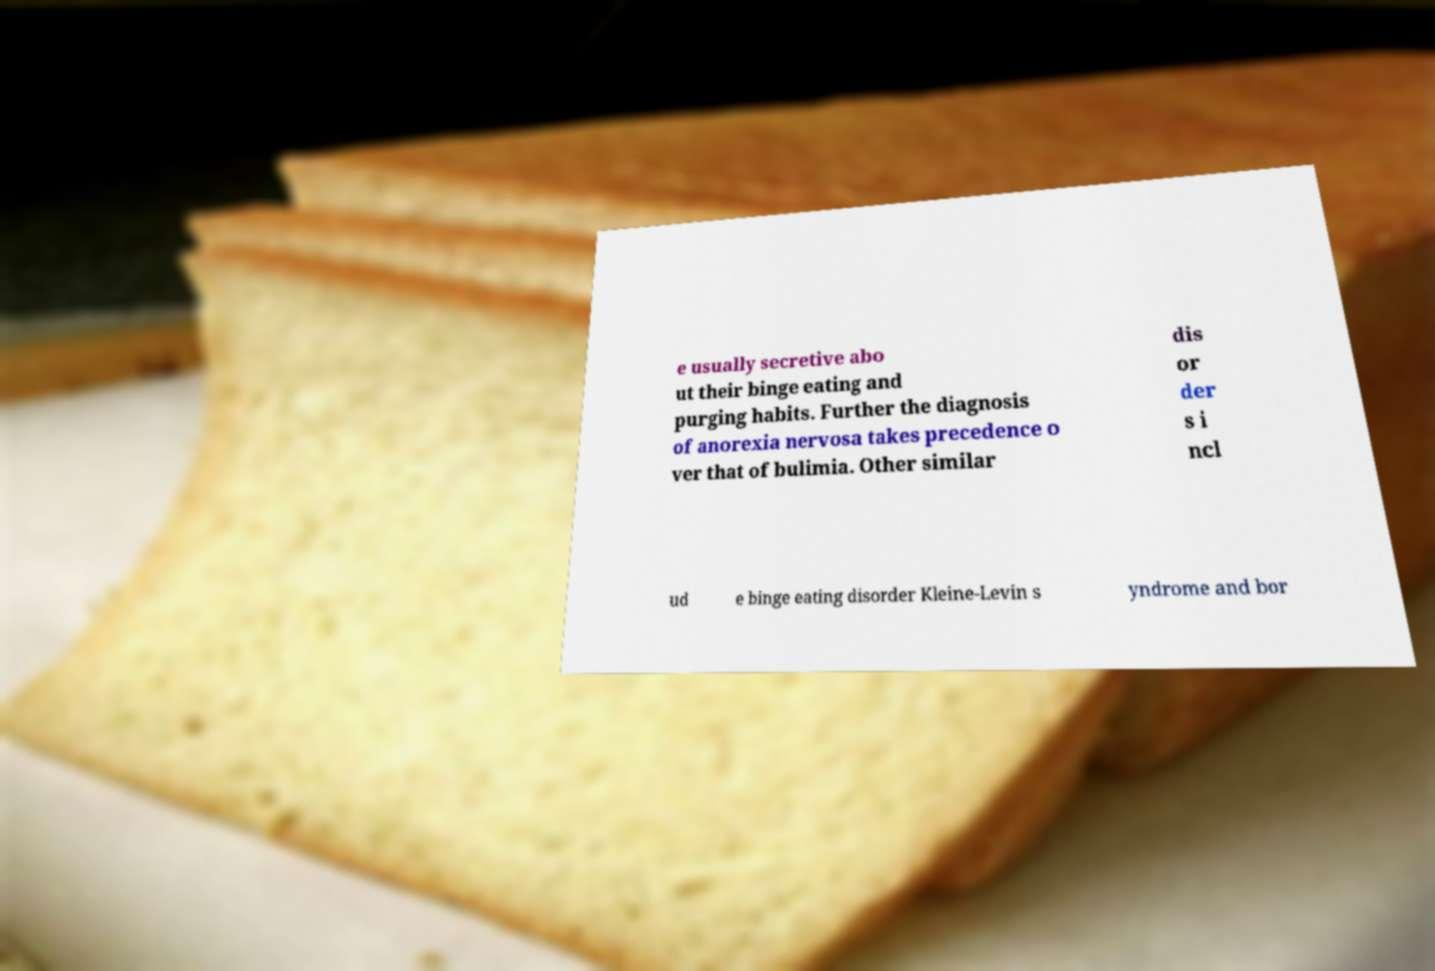Can you read and provide the text displayed in the image?This photo seems to have some interesting text. Can you extract and type it out for me? e usually secretive abo ut their binge eating and purging habits. Further the diagnosis of anorexia nervosa takes precedence o ver that of bulimia. Other similar dis or der s i ncl ud e binge eating disorder Kleine-Levin s yndrome and bor 